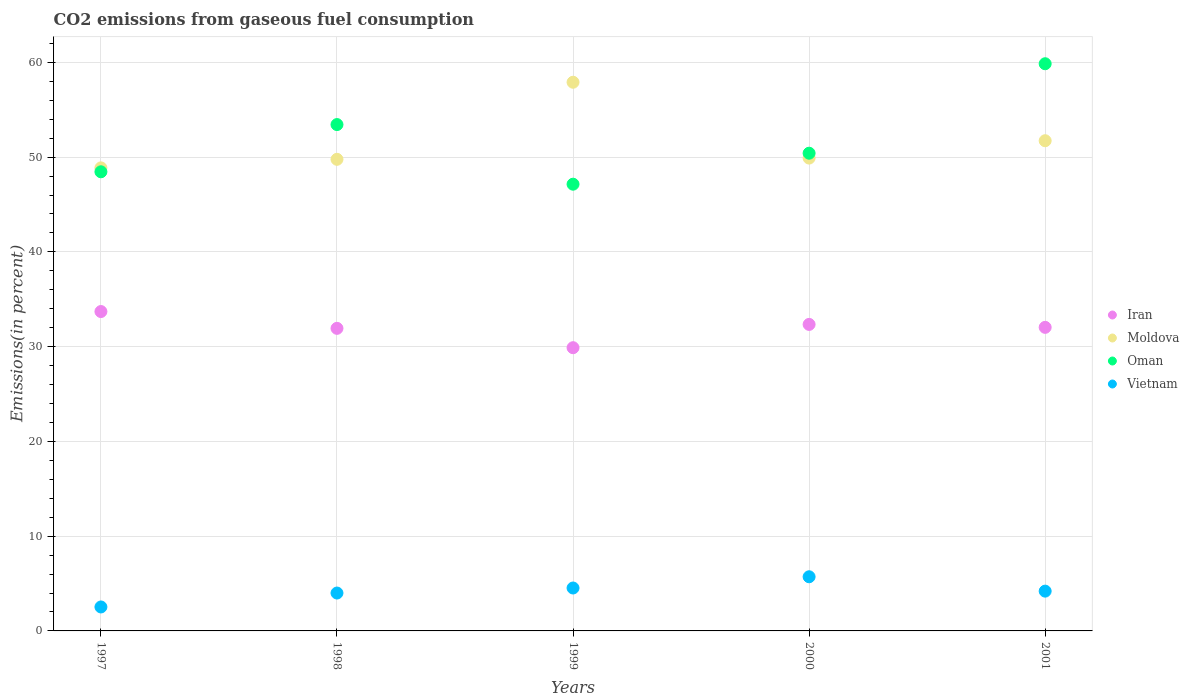How many different coloured dotlines are there?
Your answer should be compact. 4. Is the number of dotlines equal to the number of legend labels?
Keep it short and to the point. Yes. What is the total CO2 emitted in Vietnam in 1999?
Provide a short and direct response. 4.53. Across all years, what is the maximum total CO2 emitted in Iran?
Offer a very short reply. 33.7. Across all years, what is the minimum total CO2 emitted in Vietnam?
Provide a succinct answer. 2.53. What is the total total CO2 emitted in Vietnam in the graph?
Your response must be concise. 20.97. What is the difference between the total CO2 emitted in Moldova in 1997 and that in 1998?
Your answer should be very brief. -0.9. What is the difference between the total CO2 emitted in Moldova in 1999 and the total CO2 emitted in Iran in 2001?
Provide a short and direct response. 25.87. What is the average total CO2 emitted in Oman per year?
Your answer should be compact. 51.86. In the year 1999, what is the difference between the total CO2 emitted in Vietnam and total CO2 emitted in Moldova?
Your answer should be very brief. -53.37. In how many years, is the total CO2 emitted in Oman greater than 32 %?
Ensure brevity in your answer.  5. What is the ratio of the total CO2 emitted in Moldova in 1998 to that in 1999?
Your answer should be compact. 0.86. What is the difference between the highest and the second highest total CO2 emitted in Moldova?
Provide a succinct answer. 6.17. What is the difference between the highest and the lowest total CO2 emitted in Oman?
Your answer should be compact. 12.71. Is it the case that in every year, the sum of the total CO2 emitted in Vietnam and total CO2 emitted in Oman  is greater than the total CO2 emitted in Moldova?
Keep it short and to the point. No. Does the total CO2 emitted in Iran monotonically increase over the years?
Keep it short and to the point. No. Is the total CO2 emitted in Moldova strictly less than the total CO2 emitted in Vietnam over the years?
Your response must be concise. No. What is the difference between two consecutive major ticks on the Y-axis?
Your answer should be very brief. 10. Does the graph contain any zero values?
Offer a very short reply. No. How many legend labels are there?
Your response must be concise. 4. What is the title of the graph?
Offer a very short reply. CO2 emissions from gaseous fuel consumption. Does "France" appear as one of the legend labels in the graph?
Provide a succinct answer. No. What is the label or title of the X-axis?
Give a very brief answer. Years. What is the label or title of the Y-axis?
Your answer should be compact. Emissions(in percent). What is the Emissions(in percent) in Iran in 1997?
Your response must be concise. 33.7. What is the Emissions(in percent) in Moldova in 1997?
Make the answer very short. 48.86. What is the Emissions(in percent) of Oman in 1997?
Keep it short and to the point. 48.45. What is the Emissions(in percent) in Vietnam in 1997?
Provide a short and direct response. 2.53. What is the Emissions(in percent) in Iran in 1998?
Provide a succinct answer. 31.93. What is the Emissions(in percent) of Moldova in 1998?
Ensure brevity in your answer.  49.77. What is the Emissions(in percent) of Oman in 1998?
Ensure brevity in your answer.  53.43. What is the Emissions(in percent) in Vietnam in 1998?
Your answer should be compact. 4. What is the Emissions(in percent) of Iran in 1999?
Keep it short and to the point. 29.89. What is the Emissions(in percent) in Moldova in 1999?
Offer a very short reply. 57.9. What is the Emissions(in percent) of Oman in 1999?
Your answer should be compact. 47.14. What is the Emissions(in percent) of Vietnam in 1999?
Your answer should be very brief. 4.53. What is the Emissions(in percent) in Iran in 2000?
Offer a terse response. 32.34. What is the Emissions(in percent) in Moldova in 2000?
Keep it short and to the point. 49.9. What is the Emissions(in percent) of Oman in 2000?
Provide a succinct answer. 50.41. What is the Emissions(in percent) in Vietnam in 2000?
Ensure brevity in your answer.  5.71. What is the Emissions(in percent) of Iran in 2001?
Ensure brevity in your answer.  32.03. What is the Emissions(in percent) of Moldova in 2001?
Provide a succinct answer. 51.73. What is the Emissions(in percent) of Oman in 2001?
Offer a terse response. 59.85. What is the Emissions(in percent) of Vietnam in 2001?
Your answer should be very brief. 4.2. Across all years, what is the maximum Emissions(in percent) of Iran?
Provide a succinct answer. 33.7. Across all years, what is the maximum Emissions(in percent) of Moldova?
Ensure brevity in your answer.  57.9. Across all years, what is the maximum Emissions(in percent) in Oman?
Your answer should be compact. 59.85. Across all years, what is the maximum Emissions(in percent) in Vietnam?
Provide a short and direct response. 5.71. Across all years, what is the minimum Emissions(in percent) of Iran?
Make the answer very short. 29.89. Across all years, what is the minimum Emissions(in percent) of Moldova?
Offer a terse response. 48.86. Across all years, what is the minimum Emissions(in percent) in Oman?
Offer a very short reply. 47.14. Across all years, what is the minimum Emissions(in percent) of Vietnam?
Give a very brief answer. 2.53. What is the total Emissions(in percent) of Iran in the graph?
Make the answer very short. 159.9. What is the total Emissions(in percent) of Moldova in the graph?
Your answer should be very brief. 258.15. What is the total Emissions(in percent) of Oman in the graph?
Keep it short and to the point. 259.28. What is the total Emissions(in percent) in Vietnam in the graph?
Your response must be concise. 20.97. What is the difference between the Emissions(in percent) of Iran in 1997 and that in 1998?
Provide a short and direct response. 1.77. What is the difference between the Emissions(in percent) of Moldova in 1997 and that in 1998?
Your answer should be compact. -0.9. What is the difference between the Emissions(in percent) of Oman in 1997 and that in 1998?
Your response must be concise. -4.98. What is the difference between the Emissions(in percent) of Vietnam in 1997 and that in 1998?
Your answer should be compact. -1.47. What is the difference between the Emissions(in percent) of Iran in 1997 and that in 1999?
Offer a terse response. 3.82. What is the difference between the Emissions(in percent) of Moldova in 1997 and that in 1999?
Ensure brevity in your answer.  -9.04. What is the difference between the Emissions(in percent) in Oman in 1997 and that in 1999?
Ensure brevity in your answer.  1.31. What is the difference between the Emissions(in percent) in Iran in 1997 and that in 2000?
Provide a succinct answer. 1.36. What is the difference between the Emissions(in percent) of Moldova in 1997 and that in 2000?
Provide a succinct answer. -1.03. What is the difference between the Emissions(in percent) of Oman in 1997 and that in 2000?
Offer a terse response. -1.96. What is the difference between the Emissions(in percent) of Vietnam in 1997 and that in 2000?
Provide a short and direct response. -3.19. What is the difference between the Emissions(in percent) of Iran in 1997 and that in 2001?
Your response must be concise. 1.67. What is the difference between the Emissions(in percent) of Moldova in 1997 and that in 2001?
Offer a very short reply. -2.86. What is the difference between the Emissions(in percent) in Oman in 1997 and that in 2001?
Provide a succinct answer. -11.4. What is the difference between the Emissions(in percent) in Vietnam in 1997 and that in 2001?
Your answer should be very brief. -1.67. What is the difference between the Emissions(in percent) in Iran in 1998 and that in 1999?
Provide a succinct answer. 2.04. What is the difference between the Emissions(in percent) in Moldova in 1998 and that in 1999?
Your answer should be compact. -8.13. What is the difference between the Emissions(in percent) in Oman in 1998 and that in 1999?
Give a very brief answer. 6.29. What is the difference between the Emissions(in percent) of Vietnam in 1998 and that in 1999?
Keep it short and to the point. -0.53. What is the difference between the Emissions(in percent) of Iran in 1998 and that in 2000?
Make the answer very short. -0.41. What is the difference between the Emissions(in percent) of Moldova in 1998 and that in 2000?
Your answer should be compact. -0.13. What is the difference between the Emissions(in percent) in Oman in 1998 and that in 2000?
Offer a terse response. 3.02. What is the difference between the Emissions(in percent) in Vietnam in 1998 and that in 2000?
Offer a terse response. -1.72. What is the difference between the Emissions(in percent) in Iran in 1998 and that in 2001?
Make the answer very short. -0.1. What is the difference between the Emissions(in percent) in Moldova in 1998 and that in 2001?
Your answer should be compact. -1.96. What is the difference between the Emissions(in percent) in Oman in 1998 and that in 2001?
Your answer should be compact. -6.42. What is the difference between the Emissions(in percent) in Vietnam in 1998 and that in 2001?
Your response must be concise. -0.2. What is the difference between the Emissions(in percent) in Iran in 1999 and that in 2000?
Ensure brevity in your answer.  -2.46. What is the difference between the Emissions(in percent) in Moldova in 1999 and that in 2000?
Your answer should be compact. 8. What is the difference between the Emissions(in percent) in Oman in 1999 and that in 2000?
Ensure brevity in your answer.  -3.27. What is the difference between the Emissions(in percent) in Vietnam in 1999 and that in 2000?
Offer a very short reply. -1.19. What is the difference between the Emissions(in percent) of Iran in 1999 and that in 2001?
Give a very brief answer. -2.15. What is the difference between the Emissions(in percent) in Moldova in 1999 and that in 2001?
Provide a succinct answer. 6.17. What is the difference between the Emissions(in percent) in Oman in 1999 and that in 2001?
Your response must be concise. -12.71. What is the difference between the Emissions(in percent) in Vietnam in 1999 and that in 2001?
Provide a short and direct response. 0.33. What is the difference between the Emissions(in percent) of Iran in 2000 and that in 2001?
Offer a very short reply. 0.31. What is the difference between the Emissions(in percent) in Moldova in 2000 and that in 2001?
Your answer should be compact. -1.83. What is the difference between the Emissions(in percent) in Oman in 2000 and that in 2001?
Your answer should be compact. -9.44. What is the difference between the Emissions(in percent) in Vietnam in 2000 and that in 2001?
Offer a very short reply. 1.52. What is the difference between the Emissions(in percent) in Iran in 1997 and the Emissions(in percent) in Moldova in 1998?
Offer a very short reply. -16.06. What is the difference between the Emissions(in percent) in Iran in 1997 and the Emissions(in percent) in Oman in 1998?
Offer a terse response. -19.73. What is the difference between the Emissions(in percent) of Iran in 1997 and the Emissions(in percent) of Vietnam in 1998?
Provide a short and direct response. 29.7. What is the difference between the Emissions(in percent) of Moldova in 1997 and the Emissions(in percent) of Oman in 1998?
Offer a terse response. -4.57. What is the difference between the Emissions(in percent) in Moldova in 1997 and the Emissions(in percent) in Vietnam in 1998?
Your answer should be very brief. 44.87. What is the difference between the Emissions(in percent) of Oman in 1997 and the Emissions(in percent) of Vietnam in 1998?
Offer a terse response. 44.45. What is the difference between the Emissions(in percent) of Iran in 1997 and the Emissions(in percent) of Moldova in 1999?
Make the answer very short. -24.2. What is the difference between the Emissions(in percent) in Iran in 1997 and the Emissions(in percent) in Oman in 1999?
Your answer should be very brief. -13.44. What is the difference between the Emissions(in percent) of Iran in 1997 and the Emissions(in percent) of Vietnam in 1999?
Give a very brief answer. 29.17. What is the difference between the Emissions(in percent) of Moldova in 1997 and the Emissions(in percent) of Oman in 1999?
Provide a short and direct response. 1.72. What is the difference between the Emissions(in percent) in Moldova in 1997 and the Emissions(in percent) in Vietnam in 1999?
Offer a terse response. 44.34. What is the difference between the Emissions(in percent) of Oman in 1997 and the Emissions(in percent) of Vietnam in 1999?
Keep it short and to the point. 43.92. What is the difference between the Emissions(in percent) of Iran in 1997 and the Emissions(in percent) of Moldova in 2000?
Your answer should be compact. -16.19. What is the difference between the Emissions(in percent) in Iran in 1997 and the Emissions(in percent) in Oman in 2000?
Your answer should be very brief. -16.71. What is the difference between the Emissions(in percent) in Iran in 1997 and the Emissions(in percent) in Vietnam in 2000?
Your response must be concise. 27.99. What is the difference between the Emissions(in percent) of Moldova in 1997 and the Emissions(in percent) of Oman in 2000?
Your response must be concise. -1.55. What is the difference between the Emissions(in percent) of Moldova in 1997 and the Emissions(in percent) of Vietnam in 2000?
Your answer should be very brief. 43.15. What is the difference between the Emissions(in percent) of Oman in 1997 and the Emissions(in percent) of Vietnam in 2000?
Your answer should be compact. 42.73. What is the difference between the Emissions(in percent) of Iran in 1997 and the Emissions(in percent) of Moldova in 2001?
Ensure brevity in your answer.  -18.03. What is the difference between the Emissions(in percent) in Iran in 1997 and the Emissions(in percent) in Oman in 2001?
Keep it short and to the point. -26.15. What is the difference between the Emissions(in percent) of Iran in 1997 and the Emissions(in percent) of Vietnam in 2001?
Your answer should be very brief. 29.5. What is the difference between the Emissions(in percent) of Moldova in 1997 and the Emissions(in percent) of Oman in 2001?
Your answer should be compact. -10.99. What is the difference between the Emissions(in percent) in Moldova in 1997 and the Emissions(in percent) in Vietnam in 2001?
Your answer should be compact. 44.67. What is the difference between the Emissions(in percent) of Oman in 1997 and the Emissions(in percent) of Vietnam in 2001?
Make the answer very short. 44.25. What is the difference between the Emissions(in percent) in Iran in 1998 and the Emissions(in percent) in Moldova in 1999?
Your answer should be compact. -25.97. What is the difference between the Emissions(in percent) of Iran in 1998 and the Emissions(in percent) of Oman in 1999?
Provide a succinct answer. -15.21. What is the difference between the Emissions(in percent) in Iran in 1998 and the Emissions(in percent) in Vietnam in 1999?
Offer a terse response. 27.4. What is the difference between the Emissions(in percent) of Moldova in 1998 and the Emissions(in percent) of Oman in 1999?
Your response must be concise. 2.63. What is the difference between the Emissions(in percent) in Moldova in 1998 and the Emissions(in percent) in Vietnam in 1999?
Keep it short and to the point. 45.24. What is the difference between the Emissions(in percent) in Oman in 1998 and the Emissions(in percent) in Vietnam in 1999?
Your answer should be very brief. 48.9. What is the difference between the Emissions(in percent) in Iran in 1998 and the Emissions(in percent) in Moldova in 2000?
Give a very brief answer. -17.97. What is the difference between the Emissions(in percent) in Iran in 1998 and the Emissions(in percent) in Oman in 2000?
Your answer should be compact. -18.48. What is the difference between the Emissions(in percent) of Iran in 1998 and the Emissions(in percent) of Vietnam in 2000?
Your answer should be compact. 26.21. What is the difference between the Emissions(in percent) in Moldova in 1998 and the Emissions(in percent) in Oman in 2000?
Give a very brief answer. -0.64. What is the difference between the Emissions(in percent) of Moldova in 1998 and the Emissions(in percent) of Vietnam in 2000?
Ensure brevity in your answer.  44.05. What is the difference between the Emissions(in percent) of Oman in 1998 and the Emissions(in percent) of Vietnam in 2000?
Your answer should be compact. 47.72. What is the difference between the Emissions(in percent) of Iran in 1998 and the Emissions(in percent) of Moldova in 2001?
Ensure brevity in your answer.  -19.8. What is the difference between the Emissions(in percent) in Iran in 1998 and the Emissions(in percent) in Oman in 2001?
Give a very brief answer. -27.92. What is the difference between the Emissions(in percent) in Iran in 1998 and the Emissions(in percent) in Vietnam in 2001?
Your answer should be very brief. 27.73. What is the difference between the Emissions(in percent) in Moldova in 1998 and the Emissions(in percent) in Oman in 2001?
Offer a very short reply. -10.09. What is the difference between the Emissions(in percent) in Moldova in 1998 and the Emissions(in percent) in Vietnam in 2001?
Your answer should be very brief. 45.57. What is the difference between the Emissions(in percent) in Oman in 1998 and the Emissions(in percent) in Vietnam in 2001?
Your answer should be compact. 49.23. What is the difference between the Emissions(in percent) of Iran in 1999 and the Emissions(in percent) of Moldova in 2000?
Your answer should be very brief. -20.01. What is the difference between the Emissions(in percent) of Iran in 1999 and the Emissions(in percent) of Oman in 2000?
Make the answer very short. -20.52. What is the difference between the Emissions(in percent) in Iran in 1999 and the Emissions(in percent) in Vietnam in 2000?
Provide a succinct answer. 24.17. What is the difference between the Emissions(in percent) in Moldova in 1999 and the Emissions(in percent) in Oman in 2000?
Provide a short and direct response. 7.49. What is the difference between the Emissions(in percent) in Moldova in 1999 and the Emissions(in percent) in Vietnam in 2000?
Provide a short and direct response. 52.18. What is the difference between the Emissions(in percent) of Oman in 1999 and the Emissions(in percent) of Vietnam in 2000?
Provide a succinct answer. 41.43. What is the difference between the Emissions(in percent) of Iran in 1999 and the Emissions(in percent) of Moldova in 2001?
Provide a short and direct response. -21.84. What is the difference between the Emissions(in percent) of Iran in 1999 and the Emissions(in percent) of Oman in 2001?
Offer a terse response. -29.96. What is the difference between the Emissions(in percent) of Iran in 1999 and the Emissions(in percent) of Vietnam in 2001?
Make the answer very short. 25.69. What is the difference between the Emissions(in percent) in Moldova in 1999 and the Emissions(in percent) in Oman in 2001?
Offer a very short reply. -1.95. What is the difference between the Emissions(in percent) in Moldova in 1999 and the Emissions(in percent) in Vietnam in 2001?
Provide a succinct answer. 53.7. What is the difference between the Emissions(in percent) in Oman in 1999 and the Emissions(in percent) in Vietnam in 2001?
Ensure brevity in your answer.  42.94. What is the difference between the Emissions(in percent) in Iran in 2000 and the Emissions(in percent) in Moldova in 2001?
Offer a very short reply. -19.38. What is the difference between the Emissions(in percent) in Iran in 2000 and the Emissions(in percent) in Oman in 2001?
Offer a very short reply. -27.51. What is the difference between the Emissions(in percent) of Iran in 2000 and the Emissions(in percent) of Vietnam in 2001?
Give a very brief answer. 28.15. What is the difference between the Emissions(in percent) in Moldova in 2000 and the Emissions(in percent) in Oman in 2001?
Give a very brief answer. -9.96. What is the difference between the Emissions(in percent) in Moldova in 2000 and the Emissions(in percent) in Vietnam in 2001?
Offer a terse response. 45.7. What is the difference between the Emissions(in percent) of Oman in 2000 and the Emissions(in percent) of Vietnam in 2001?
Offer a very short reply. 46.21. What is the average Emissions(in percent) of Iran per year?
Offer a very short reply. 31.98. What is the average Emissions(in percent) of Moldova per year?
Keep it short and to the point. 51.63. What is the average Emissions(in percent) of Oman per year?
Provide a succinct answer. 51.86. What is the average Emissions(in percent) of Vietnam per year?
Provide a succinct answer. 4.19. In the year 1997, what is the difference between the Emissions(in percent) in Iran and Emissions(in percent) in Moldova?
Provide a succinct answer. -15.16. In the year 1997, what is the difference between the Emissions(in percent) of Iran and Emissions(in percent) of Oman?
Offer a terse response. -14.75. In the year 1997, what is the difference between the Emissions(in percent) in Iran and Emissions(in percent) in Vietnam?
Give a very brief answer. 31.17. In the year 1997, what is the difference between the Emissions(in percent) in Moldova and Emissions(in percent) in Oman?
Provide a short and direct response. 0.41. In the year 1997, what is the difference between the Emissions(in percent) in Moldova and Emissions(in percent) in Vietnam?
Give a very brief answer. 46.34. In the year 1997, what is the difference between the Emissions(in percent) in Oman and Emissions(in percent) in Vietnam?
Offer a terse response. 45.92. In the year 1998, what is the difference between the Emissions(in percent) in Iran and Emissions(in percent) in Moldova?
Your answer should be very brief. -17.84. In the year 1998, what is the difference between the Emissions(in percent) of Iran and Emissions(in percent) of Oman?
Provide a short and direct response. -21.5. In the year 1998, what is the difference between the Emissions(in percent) of Iran and Emissions(in percent) of Vietnam?
Provide a short and direct response. 27.93. In the year 1998, what is the difference between the Emissions(in percent) of Moldova and Emissions(in percent) of Oman?
Ensure brevity in your answer.  -3.67. In the year 1998, what is the difference between the Emissions(in percent) of Moldova and Emissions(in percent) of Vietnam?
Offer a very short reply. 45.77. In the year 1998, what is the difference between the Emissions(in percent) in Oman and Emissions(in percent) in Vietnam?
Provide a succinct answer. 49.43. In the year 1999, what is the difference between the Emissions(in percent) of Iran and Emissions(in percent) of Moldova?
Offer a terse response. -28.01. In the year 1999, what is the difference between the Emissions(in percent) of Iran and Emissions(in percent) of Oman?
Your answer should be very brief. -17.25. In the year 1999, what is the difference between the Emissions(in percent) in Iran and Emissions(in percent) in Vietnam?
Give a very brief answer. 25.36. In the year 1999, what is the difference between the Emissions(in percent) of Moldova and Emissions(in percent) of Oman?
Make the answer very short. 10.76. In the year 1999, what is the difference between the Emissions(in percent) in Moldova and Emissions(in percent) in Vietnam?
Make the answer very short. 53.37. In the year 1999, what is the difference between the Emissions(in percent) of Oman and Emissions(in percent) of Vietnam?
Make the answer very short. 42.61. In the year 2000, what is the difference between the Emissions(in percent) in Iran and Emissions(in percent) in Moldova?
Provide a short and direct response. -17.55. In the year 2000, what is the difference between the Emissions(in percent) of Iran and Emissions(in percent) of Oman?
Ensure brevity in your answer.  -18.07. In the year 2000, what is the difference between the Emissions(in percent) in Iran and Emissions(in percent) in Vietnam?
Your answer should be compact. 26.63. In the year 2000, what is the difference between the Emissions(in percent) in Moldova and Emissions(in percent) in Oman?
Your answer should be compact. -0.51. In the year 2000, what is the difference between the Emissions(in percent) in Moldova and Emissions(in percent) in Vietnam?
Provide a succinct answer. 44.18. In the year 2000, what is the difference between the Emissions(in percent) in Oman and Emissions(in percent) in Vietnam?
Provide a succinct answer. 44.7. In the year 2001, what is the difference between the Emissions(in percent) in Iran and Emissions(in percent) in Moldova?
Provide a succinct answer. -19.69. In the year 2001, what is the difference between the Emissions(in percent) of Iran and Emissions(in percent) of Oman?
Provide a short and direct response. -27.82. In the year 2001, what is the difference between the Emissions(in percent) in Iran and Emissions(in percent) in Vietnam?
Ensure brevity in your answer.  27.84. In the year 2001, what is the difference between the Emissions(in percent) of Moldova and Emissions(in percent) of Oman?
Give a very brief answer. -8.12. In the year 2001, what is the difference between the Emissions(in percent) of Moldova and Emissions(in percent) of Vietnam?
Ensure brevity in your answer.  47.53. In the year 2001, what is the difference between the Emissions(in percent) of Oman and Emissions(in percent) of Vietnam?
Your answer should be compact. 55.65. What is the ratio of the Emissions(in percent) of Iran in 1997 to that in 1998?
Keep it short and to the point. 1.06. What is the ratio of the Emissions(in percent) in Moldova in 1997 to that in 1998?
Give a very brief answer. 0.98. What is the ratio of the Emissions(in percent) of Oman in 1997 to that in 1998?
Your response must be concise. 0.91. What is the ratio of the Emissions(in percent) in Vietnam in 1997 to that in 1998?
Ensure brevity in your answer.  0.63. What is the ratio of the Emissions(in percent) in Iran in 1997 to that in 1999?
Keep it short and to the point. 1.13. What is the ratio of the Emissions(in percent) in Moldova in 1997 to that in 1999?
Give a very brief answer. 0.84. What is the ratio of the Emissions(in percent) of Oman in 1997 to that in 1999?
Make the answer very short. 1.03. What is the ratio of the Emissions(in percent) in Vietnam in 1997 to that in 1999?
Your answer should be very brief. 0.56. What is the ratio of the Emissions(in percent) in Iran in 1997 to that in 2000?
Offer a very short reply. 1.04. What is the ratio of the Emissions(in percent) of Moldova in 1997 to that in 2000?
Your answer should be compact. 0.98. What is the ratio of the Emissions(in percent) of Oman in 1997 to that in 2000?
Offer a very short reply. 0.96. What is the ratio of the Emissions(in percent) of Vietnam in 1997 to that in 2000?
Offer a terse response. 0.44. What is the ratio of the Emissions(in percent) in Iran in 1997 to that in 2001?
Offer a very short reply. 1.05. What is the ratio of the Emissions(in percent) in Moldova in 1997 to that in 2001?
Your answer should be compact. 0.94. What is the ratio of the Emissions(in percent) in Oman in 1997 to that in 2001?
Offer a very short reply. 0.81. What is the ratio of the Emissions(in percent) of Vietnam in 1997 to that in 2001?
Your answer should be very brief. 0.6. What is the ratio of the Emissions(in percent) of Iran in 1998 to that in 1999?
Give a very brief answer. 1.07. What is the ratio of the Emissions(in percent) of Moldova in 1998 to that in 1999?
Provide a short and direct response. 0.86. What is the ratio of the Emissions(in percent) in Oman in 1998 to that in 1999?
Your answer should be compact. 1.13. What is the ratio of the Emissions(in percent) of Vietnam in 1998 to that in 1999?
Your response must be concise. 0.88. What is the ratio of the Emissions(in percent) of Iran in 1998 to that in 2000?
Make the answer very short. 0.99. What is the ratio of the Emissions(in percent) of Oman in 1998 to that in 2000?
Keep it short and to the point. 1.06. What is the ratio of the Emissions(in percent) in Vietnam in 1998 to that in 2000?
Provide a succinct answer. 0.7. What is the ratio of the Emissions(in percent) of Moldova in 1998 to that in 2001?
Offer a very short reply. 0.96. What is the ratio of the Emissions(in percent) in Oman in 1998 to that in 2001?
Provide a succinct answer. 0.89. What is the ratio of the Emissions(in percent) in Vietnam in 1998 to that in 2001?
Your answer should be compact. 0.95. What is the ratio of the Emissions(in percent) in Iran in 1999 to that in 2000?
Give a very brief answer. 0.92. What is the ratio of the Emissions(in percent) in Moldova in 1999 to that in 2000?
Offer a very short reply. 1.16. What is the ratio of the Emissions(in percent) of Oman in 1999 to that in 2000?
Keep it short and to the point. 0.94. What is the ratio of the Emissions(in percent) of Vietnam in 1999 to that in 2000?
Keep it short and to the point. 0.79. What is the ratio of the Emissions(in percent) of Iran in 1999 to that in 2001?
Make the answer very short. 0.93. What is the ratio of the Emissions(in percent) in Moldova in 1999 to that in 2001?
Offer a terse response. 1.12. What is the ratio of the Emissions(in percent) in Oman in 1999 to that in 2001?
Provide a short and direct response. 0.79. What is the ratio of the Emissions(in percent) of Vietnam in 1999 to that in 2001?
Your response must be concise. 1.08. What is the ratio of the Emissions(in percent) of Iran in 2000 to that in 2001?
Make the answer very short. 1.01. What is the ratio of the Emissions(in percent) of Moldova in 2000 to that in 2001?
Keep it short and to the point. 0.96. What is the ratio of the Emissions(in percent) in Oman in 2000 to that in 2001?
Give a very brief answer. 0.84. What is the ratio of the Emissions(in percent) of Vietnam in 2000 to that in 2001?
Provide a short and direct response. 1.36. What is the difference between the highest and the second highest Emissions(in percent) in Iran?
Ensure brevity in your answer.  1.36. What is the difference between the highest and the second highest Emissions(in percent) in Moldova?
Ensure brevity in your answer.  6.17. What is the difference between the highest and the second highest Emissions(in percent) of Oman?
Provide a short and direct response. 6.42. What is the difference between the highest and the second highest Emissions(in percent) of Vietnam?
Ensure brevity in your answer.  1.19. What is the difference between the highest and the lowest Emissions(in percent) in Iran?
Your response must be concise. 3.82. What is the difference between the highest and the lowest Emissions(in percent) in Moldova?
Offer a terse response. 9.04. What is the difference between the highest and the lowest Emissions(in percent) in Oman?
Offer a terse response. 12.71. What is the difference between the highest and the lowest Emissions(in percent) of Vietnam?
Give a very brief answer. 3.19. 